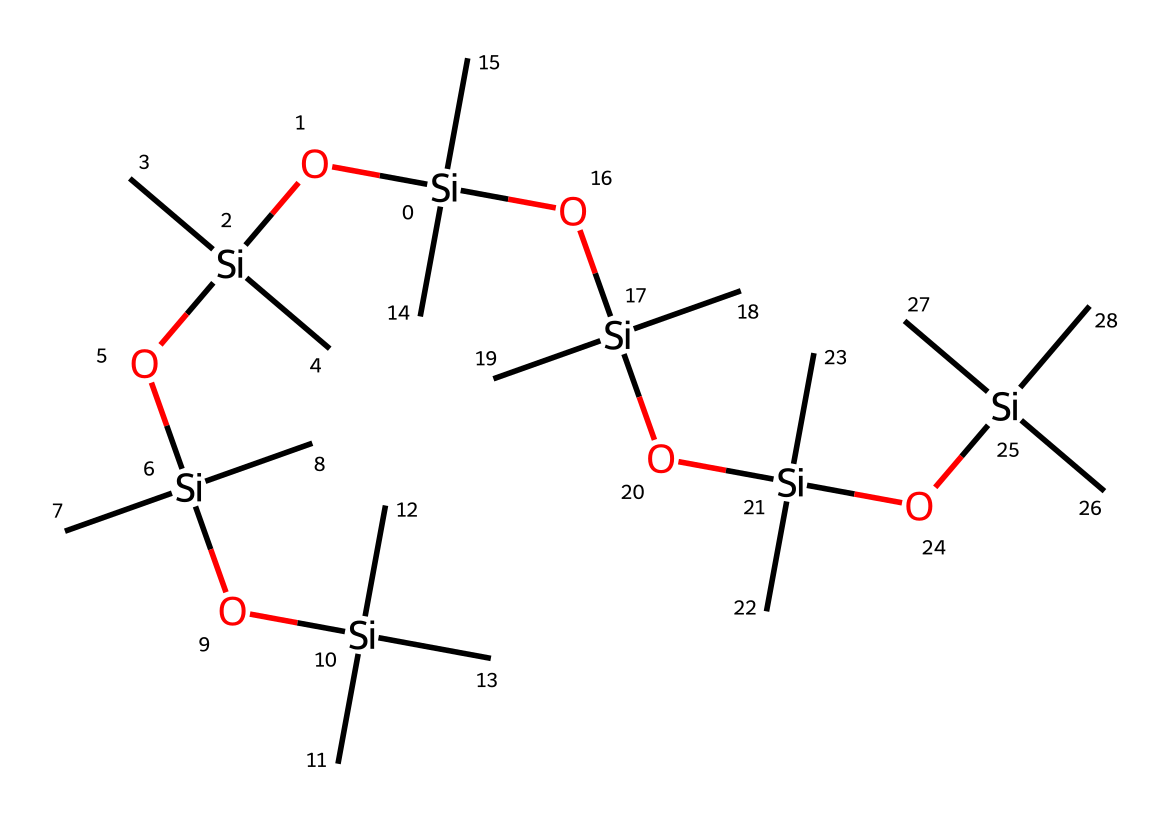What is the central atom in this silane structure? The structure prominently features silicon atoms, which are key in silanes. The central atom, based on the SMILES representation, is silicon.
Answer: silicon How many silicon atoms are present in the chemical structure? By analyzing the SMILES notation, each occurrence of [Si] indicates a silicon atom. In the provided SMILES, there are 6 occurrences of [Si].
Answer: 6 What type of functional groups are prevalent in this silane structure? The structure includes multiple hydroxyl (–OH) groups due to the presence of oxygen bonded to silicon in the silanol form. These hydroxyl groups are characteristic of silanes.
Answer: hydroxyl How many branches are there in this silane molecule? The structure reveals several branches stemming from the central silicon atoms, formed by the methyl groups (–C) that are attached. There are a total of 6 branches when counting each of the 6 silicon atoms' substitutes.
Answer: 6 What property do the multiple hydroxyl groups confer to this silane-based adhesive? The presence of multiple hydroxyl groups typically enhances the adhesive properties of the silane, improving bonding strength to substrates by allowing hydrogen bonding and cross-linking.
Answer: adhesive properties Based on the structure, what can be inferred about the viscosity of this silane compound? Due to the extensive branching and presence of multiple functional groups, the compound is likely to be viscous, as branched silanes generally exhibit higher viscosity compared to their linear counterparts.
Answer: viscous 